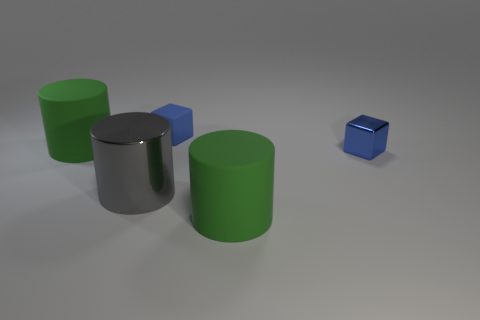How many other objects are the same color as the tiny metallic cube?
Your answer should be very brief. 1. There is a gray shiny thing that is to the left of the tiny blue metal thing; is its shape the same as the tiny shiny thing?
Your answer should be very brief. No. Is there any other thing that has the same color as the small matte cube?
Your answer should be very brief. Yes. There is a blue object that is the same material as the large gray cylinder; what is its size?
Your answer should be very brief. Small. There is a blue thing that is to the right of the tiny blue block that is behind the tiny blue block in front of the small blue matte cube; what is it made of?
Give a very brief answer. Metal. Is the number of gray cylinders less than the number of green matte cylinders?
Provide a short and direct response. Yes. The thing that is the same color as the small metal cube is what shape?
Your response must be concise. Cube. There is a metallic object on the right side of the blue rubber cube; is it the same color as the tiny rubber cube?
Ensure brevity in your answer.  Yes. There is a large green object in front of the large gray thing; what number of tiny blue cubes are to the left of it?
Your response must be concise. 1. What color is the shiny cube that is the same size as the blue rubber object?
Provide a short and direct response. Blue. 